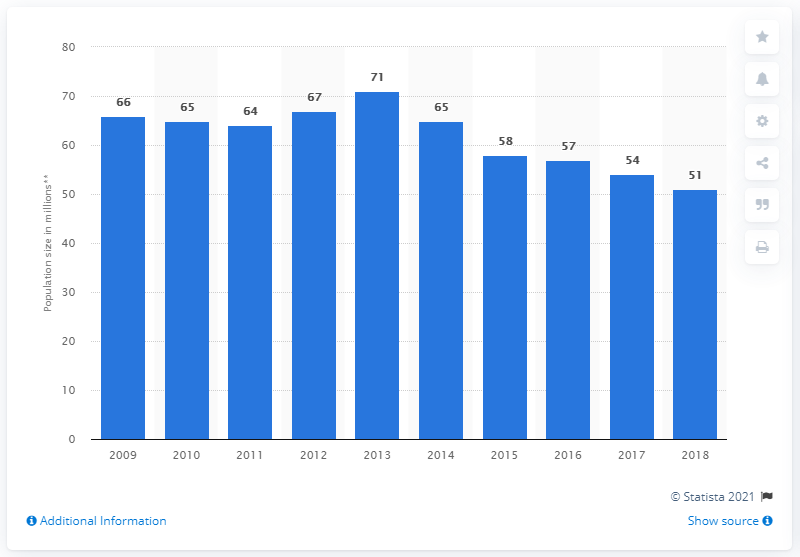Point out several critical features in this image. The estimated population of pets in the UK as of 2018 is 51 million. There is a significant market for pet food and accessories in the UK, indicating a high demand for these products among consumers. 